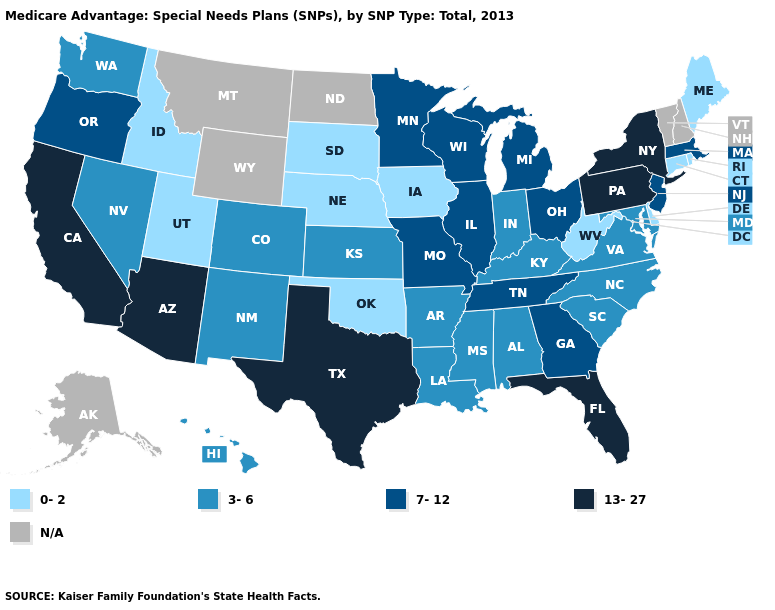Which states have the lowest value in the USA?
Keep it brief. Connecticut, Delaware, Iowa, Idaho, Maine, Nebraska, Oklahoma, Rhode Island, South Dakota, Utah, West Virginia. Does Florida have the highest value in the USA?
Answer briefly. Yes. Does Arizona have the lowest value in the USA?
Short answer required. No. What is the lowest value in the USA?
Give a very brief answer. 0-2. What is the value of Massachusetts?
Answer briefly. 7-12. Among the states that border Tennessee , which have the highest value?
Short answer required. Georgia, Missouri. What is the value of Nevada?
Answer briefly. 3-6. What is the value of Idaho?
Give a very brief answer. 0-2. Does Texas have the highest value in the South?
Quick response, please. Yes. What is the highest value in the USA?
Concise answer only. 13-27. What is the highest value in the South ?
Answer briefly. 13-27. Among the states that border Idaho , which have the highest value?
Short answer required. Oregon. Does Washington have the lowest value in the West?
Short answer required. No. 